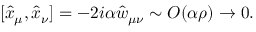Convert formula to latex. <formula><loc_0><loc_0><loc_500><loc_500>[ \hat { x } _ { \mu } , \hat { x } _ { \nu } ] = - 2 i \alpha \hat { w } _ { \mu \nu } \sim O ( \alpha \rho ) \rightarrow 0 .</formula> 